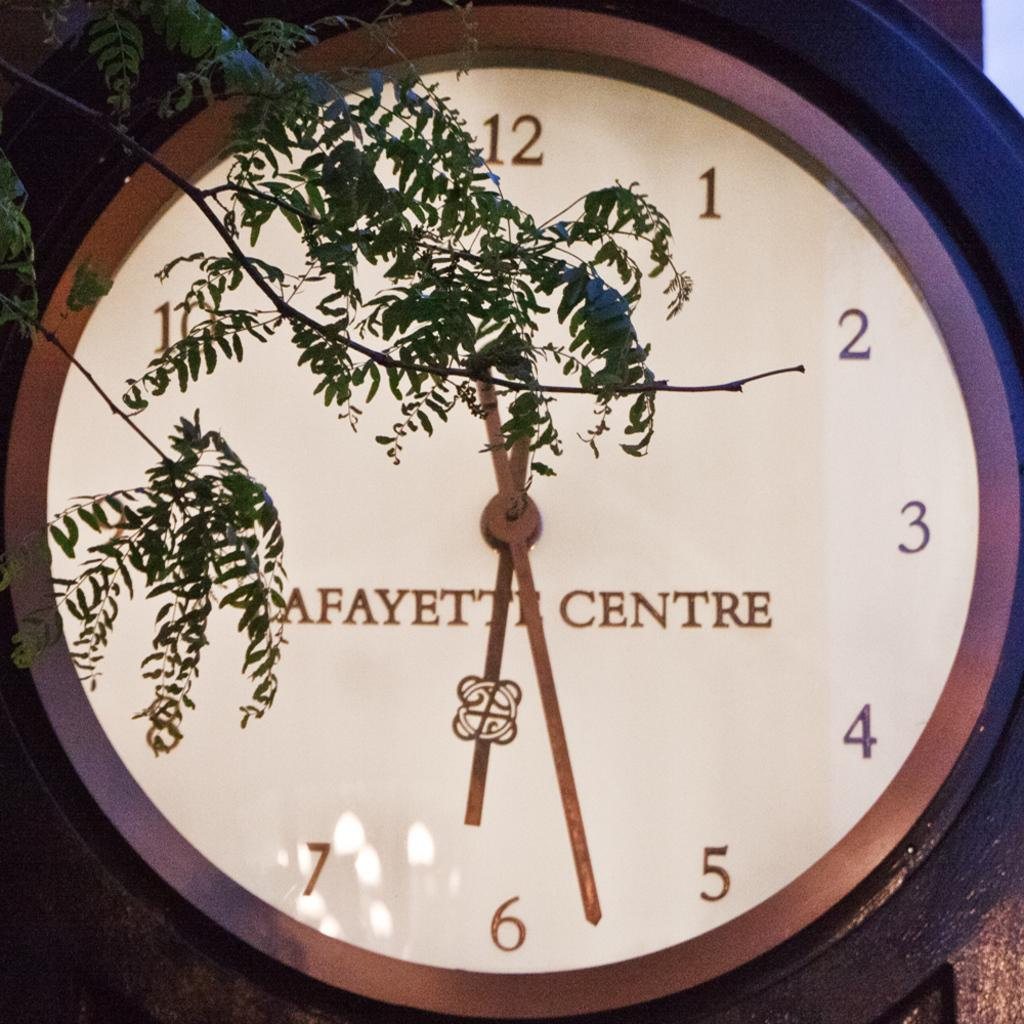Provide a one-sentence caption for the provided image. a clock that has lafayette centre on it. 